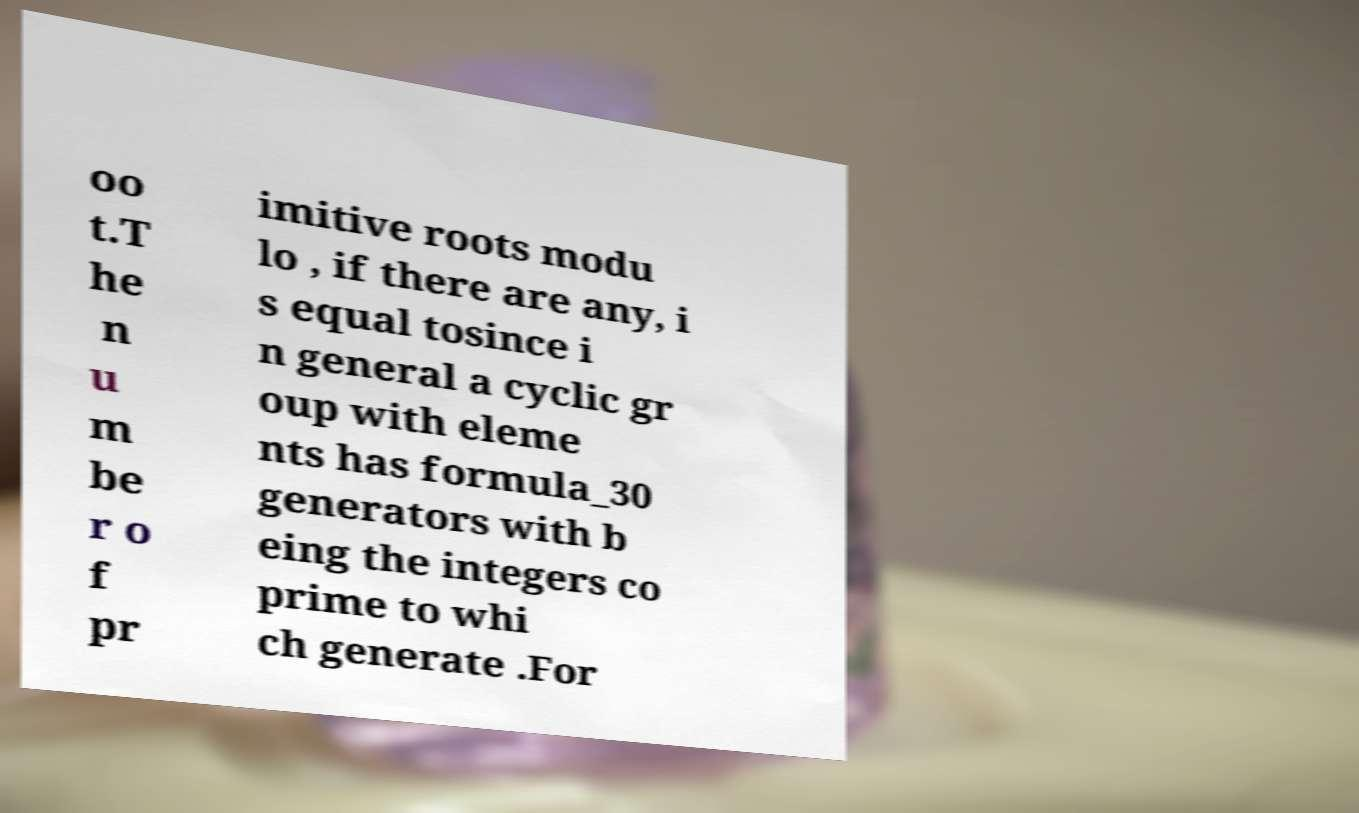What messages or text are displayed in this image? I need them in a readable, typed format. oo t.T he n u m be r o f pr imitive roots modu lo , if there are any, i s equal tosince i n general a cyclic gr oup with eleme nts has formula_30 generators with b eing the integers co prime to whi ch generate .For 